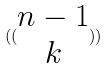Convert formula to latex. <formula><loc_0><loc_0><loc_500><loc_500>( ( \begin{matrix} n - 1 \\ k \end{matrix} ) )</formula> 